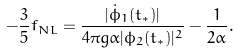<formula> <loc_0><loc_0><loc_500><loc_500>- \frac { 3 } { 5 } f _ { N L } = \frac { | \dot { \phi } _ { 1 } ( t _ { * } ) | } { 4 \pi g \alpha | \phi _ { 2 } ( t _ { * } ) | ^ { 2 } } - \frac { 1 } { 2 \alpha } .</formula> 